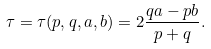Convert formula to latex. <formula><loc_0><loc_0><loc_500><loc_500>\tau = \tau ( p , q , a , b ) = 2 \frac { q a - p b } { p + q } .</formula> 